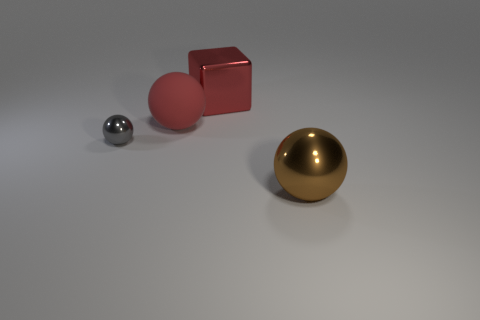Is there anything else that has the same material as the large red ball?
Your answer should be very brief. No. Do the brown metallic sphere and the red rubber sphere have the same size?
Provide a short and direct response. Yes. Is the number of small shiny things that are on the left side of the small thing less than the number of small things to the left of the big red metal thing?
Your response must be concise. Yes. There is a sphere that is both in front of the big red rubber thing and to the right of the gray thing; what is its size?
Give a very brief answer. Large. Is there a tiny thing that is to the right of the big sphere that is left of the ball that is in front of the gray metal thing?
Offer a very short reply. No. Is there a cube?
Give a very brief answer. Yes. Are there more cubes behind the block than tiny shiny balls in front of the matte object?
Give a very brief answer. No. What is the size of the cube that is the same material as the gray thing?
Make the answer very short. Large. There is a metal object that is left of the large red thing to the right of the large ball behind the big metallic sphere; how big is it?
Your answer should be compact. Small. The metal sphere that is to the left of the big brown metallic object is what color?
Keep it short and to the point. Gray. 